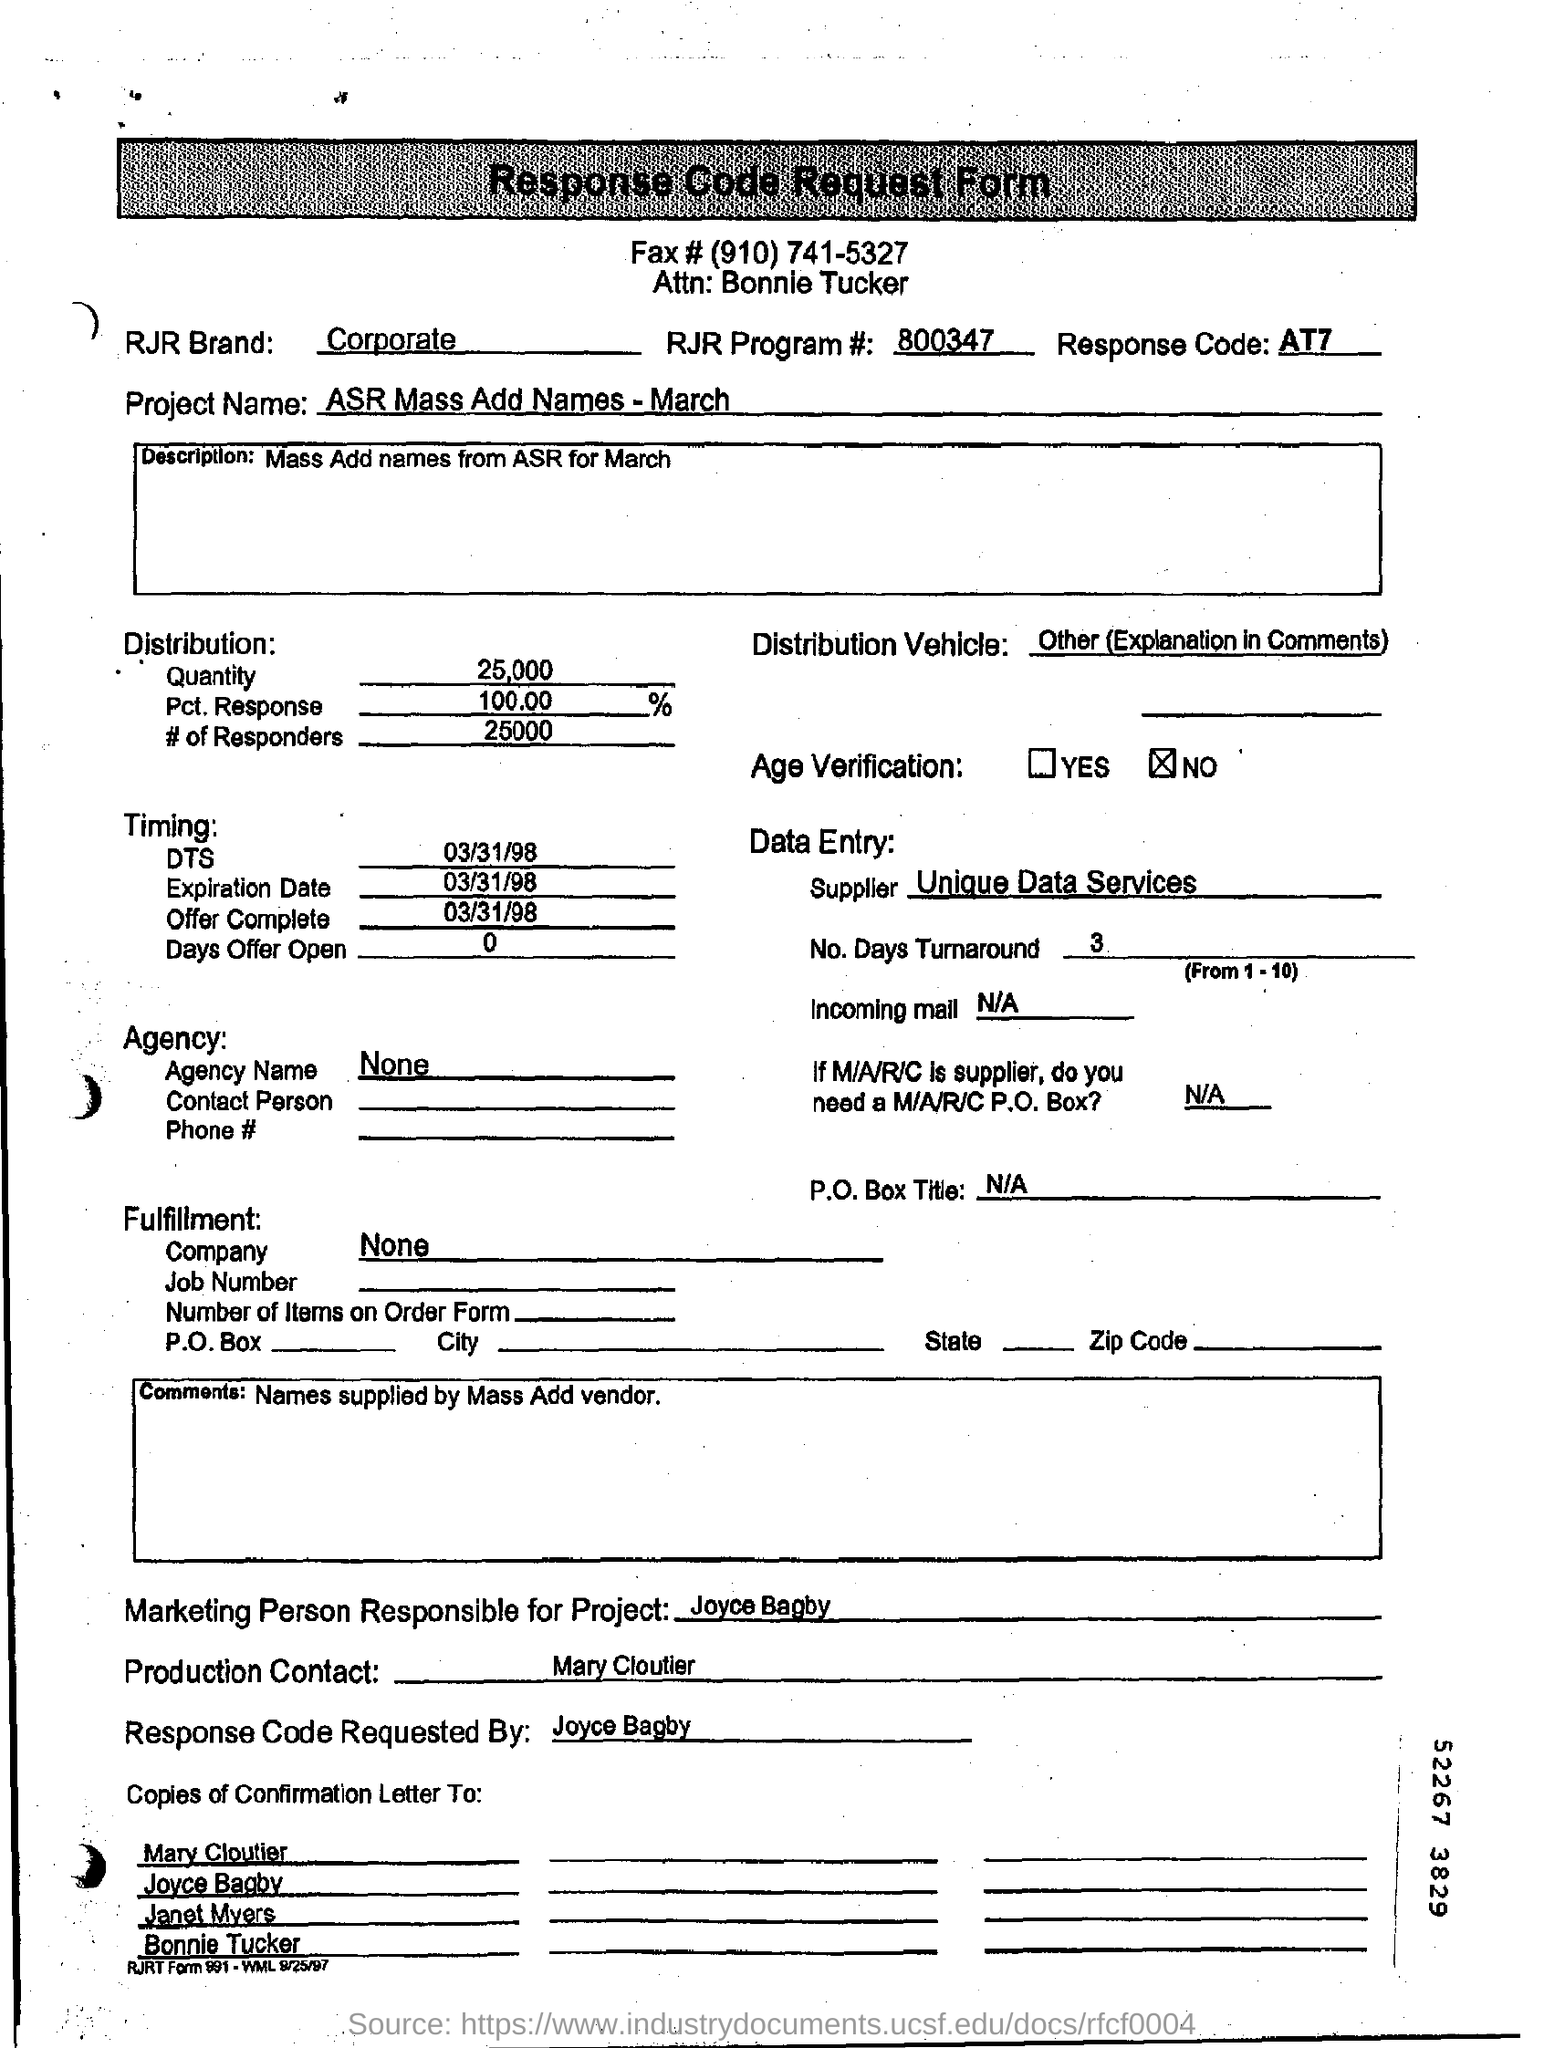What is the Response Code mentioned?
Provide a succinct answer. AT7. What is the Project Name ?
Your response must be concise. ASR Mass Add Names - March. What is given in the Comments section of the form ?
Your answer should be very brief. Names supplied by Mass Add vendor. What is the expiration date ?
Your response must be concise. 03/31/98. Who is the Production contact ?
Give a very brief answer. Mary Cloutier. 